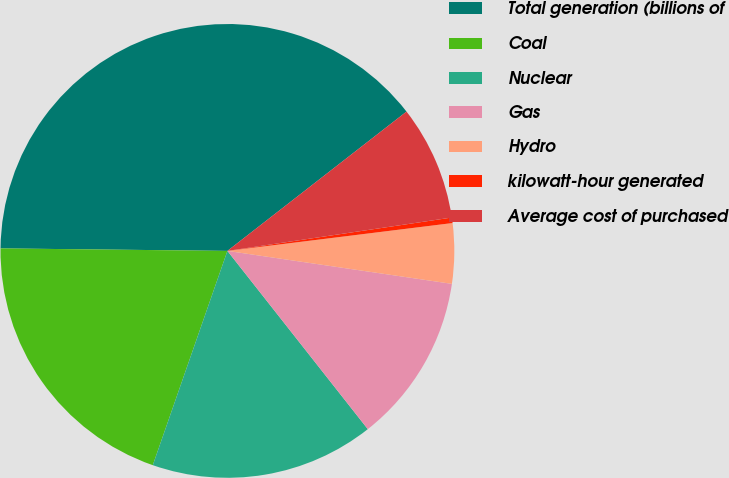Convert chart. <chart><loc_0><loc_0><loc_500><loc_500><pie_chart><fcel>Total generation (billions of<fcel>Coal<fcel>Nuclear<fcel>Gas<fcel>Hydro<fcel>kilowatt-hour generated<fcel>Average cost of purchased<nl><fcel>39.3%<fcel>19.84%<fcel>15.95%<fcel>12.06%<fcel>4.28%<fcel>0.39%<fcel>8.17%<nl></chart> 